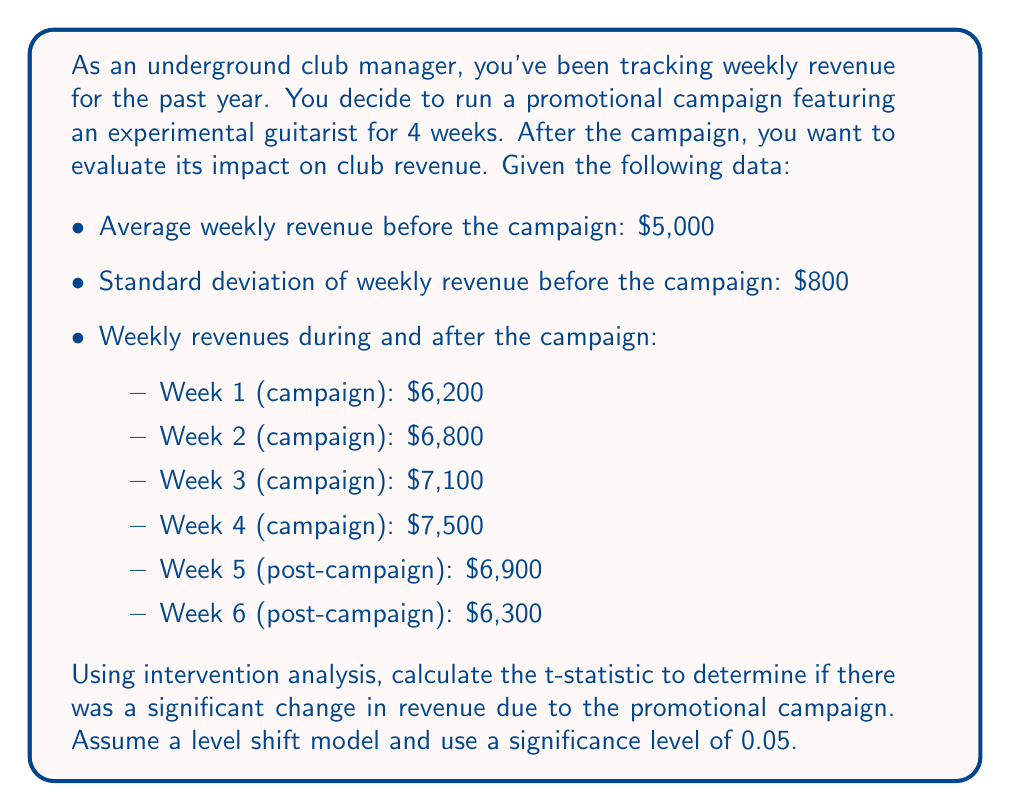Provide a solution to this math problem. To evaluate the impact of the promotional campaign on club revenue using intervention analysis, we'll follow these steps:

1) First, we need to calculate the mean revenue during and after the intervention:

   $$\bar{X}_\text{intervention} = \frac{6200 + 6800 + 7100 + 7500 + 6900 + 6300}{6} = 6800$$

2) Next, we calculate the difference between the intervention mean and the pre-intervention mean:

   $$\delta = \bar{X}_\text{intervention} - \bar{X}_\text{pre-intervention} = 6800 - 5000 = 1800$$

3) For a level shift model, we use the t-statistic formula:

   $$t = \frac{\delta}{s_e \sqrt{\frac{1}{n}}}$$

   Where:
   - $\delta$ is the difference in means
   - $s_e$ is the standard error (which we'll assume is equal to the pre-intervention standard deviation)
   - $n$ is the number of post-intervention observations

4) Plugging in our values:

   $$t = \frac{1800}{800 \sqrt{\frac{1}{6}}} = \frac{1800}{800 \cdot 0.4082} = \frac{1800}{326.56} = 5.51$$

5) To determine significance, we compare this t-statistic to the critical value from a t-distribution with n-1 = 5 degrees of freedom at a 0.05 significance level. The critical value for a two-tailed test is approximately 2.571.

6) Since our calculated t-statistic (5.51) is greater than the critical value (2.571), we can conclude that there was a significant change in revenue due to the promotional campaign.
Answer: The calculated t-statistic is 5.51, which is greater than the critical value of 2.571 at a 0.05 significance level. Therefore, we conclude that the promotional campaign had a statistically significant positive impact on club revenue. 